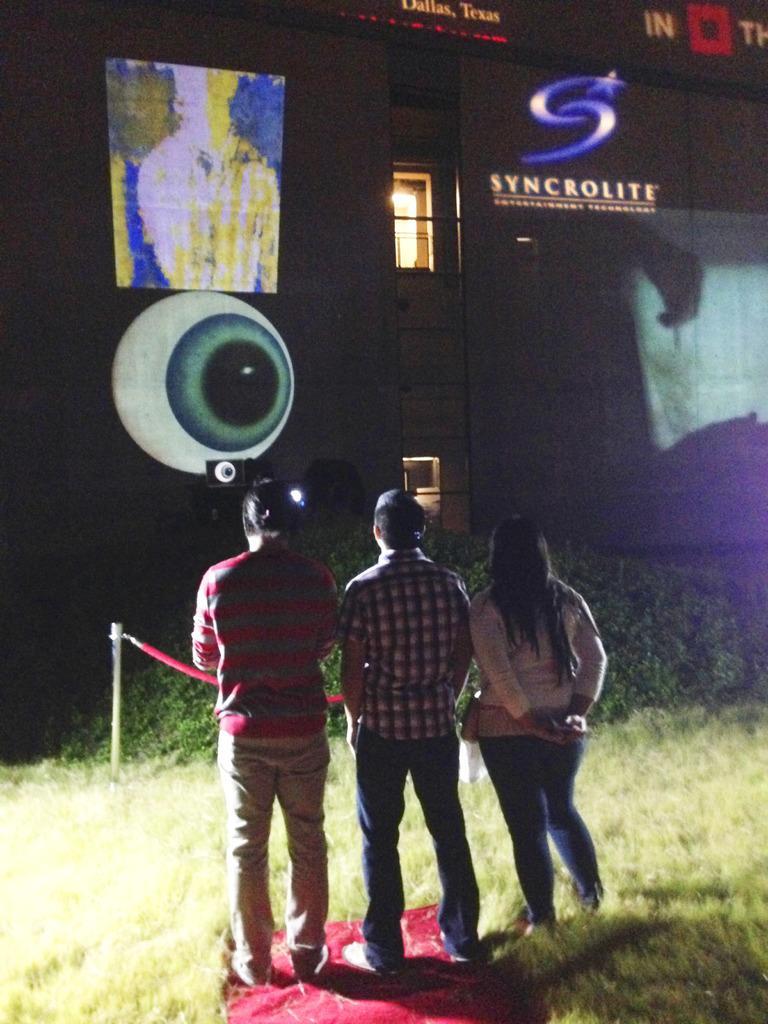Can you describe this image briefly? In this image we can see three people, in front of them there are some texts and images on the wall, there are plants, grass, window, also we can see projector, and a speaker. 